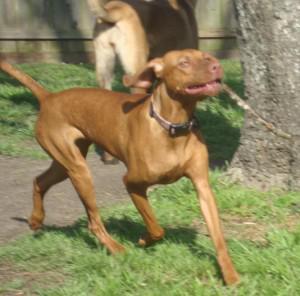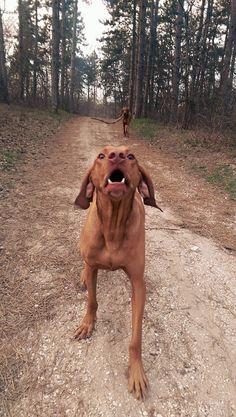The first image is the image on the left, the second image is the image on the right. Evaluate the accuracy of this statement regarding the images: "One dog is laying down.". Is it true? Answer yes or no. No. The first image is the image on the left, the second image is the image on the right. Evaluate the accuracy of this statement regarding the images: "In total, two dogs are outdoors with a wooden stick grasped in their mouth.". Is it true? Answer yes or no. No. 